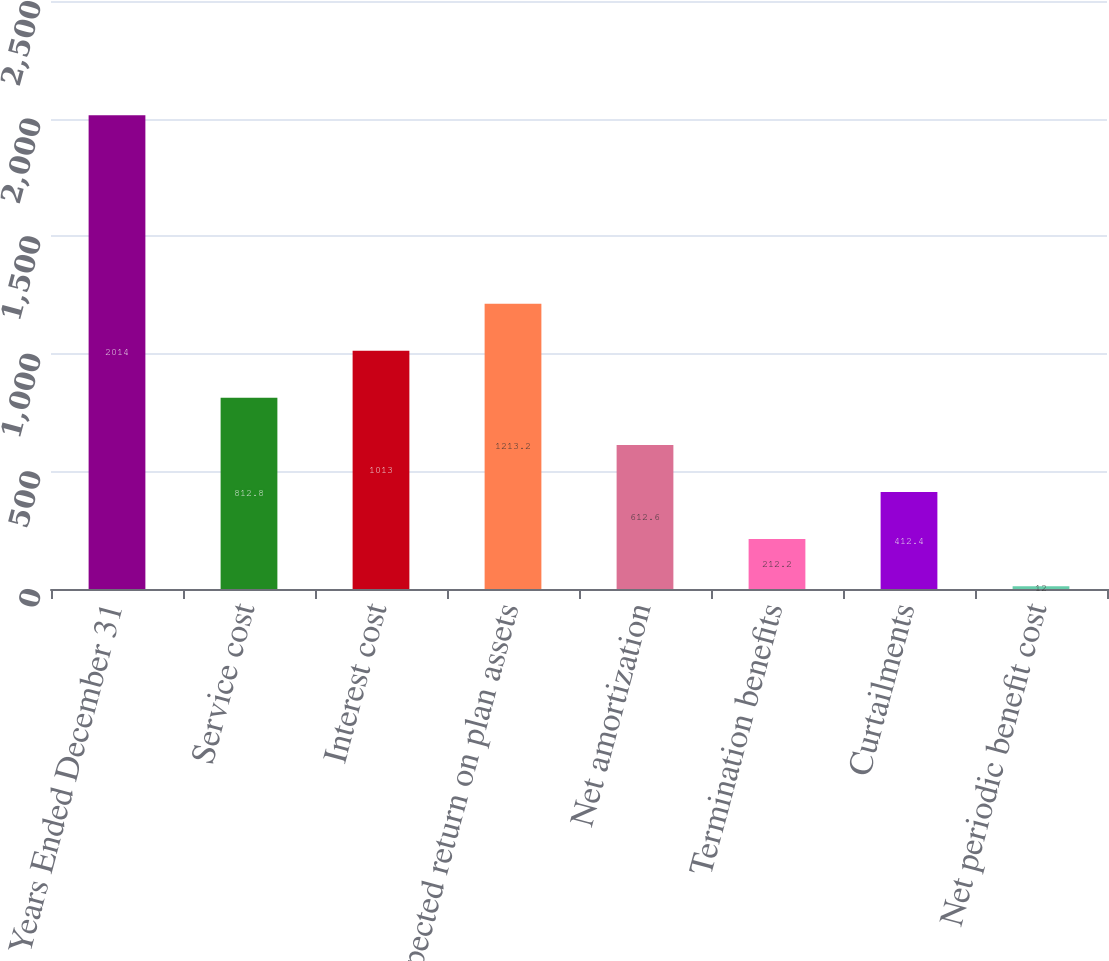<chart> <loc_0><loc_0><loc_500><loc_500><bar_chart><fcel>Years Ended December 31<fcel>Service cost<fcel>Interest cost<fcel>Expected return on plan assets<fcel>Net amortization<fcel>Termination benefits<fcel>Curtailments<fcel>Net periodic benefit cost<nl><fcel>2014<fcel>812.8<fcel>1013<fcel>1213.2<fcel>612.6<fcel>212.2<fcel>412.4<fcel>12<nl></chart> 